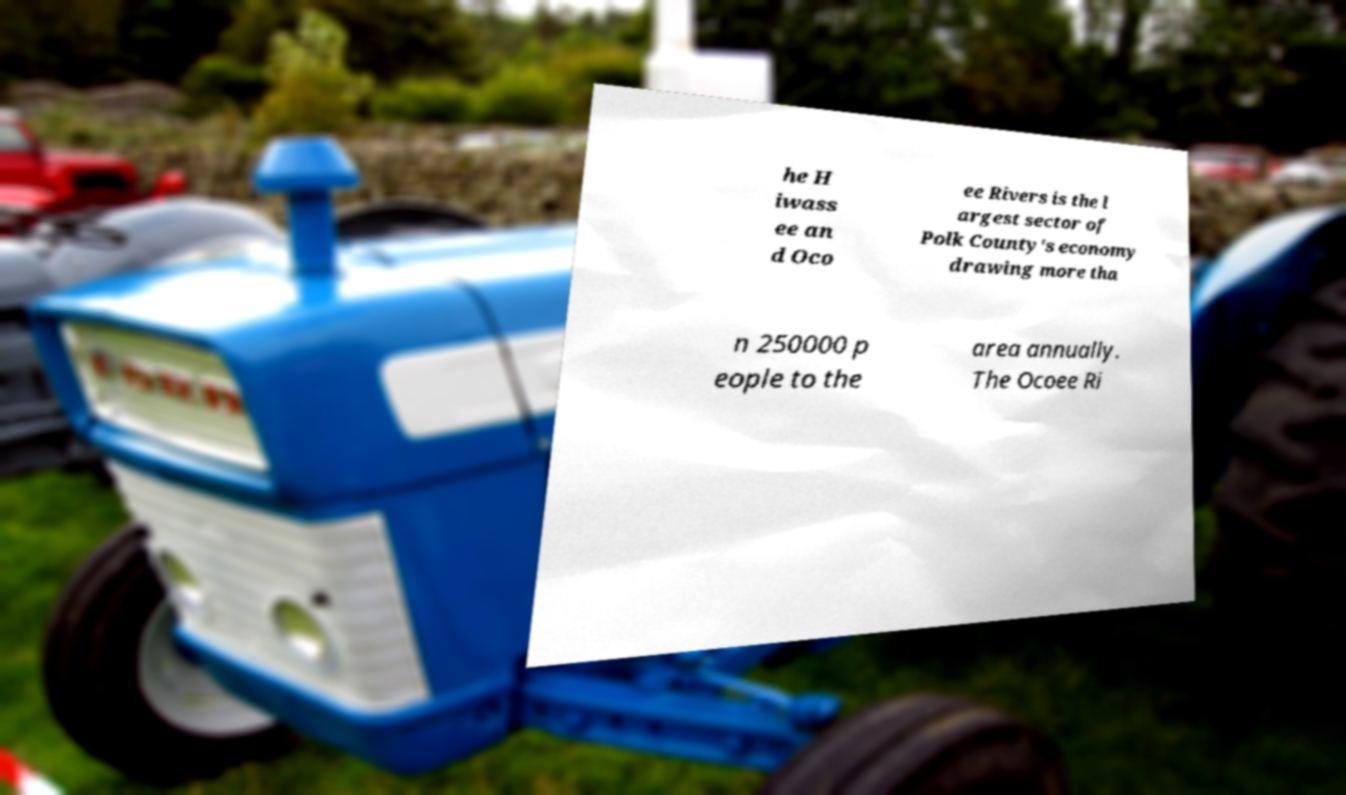For documentation purposes, I need the text within this image transcribed. Could you provide that? he H iwass ee an d Oco ee Rivers is the l argest sector of Polk County's economy drawing more tha n 250000 p eople to the area annually. The Ocoee Ri 